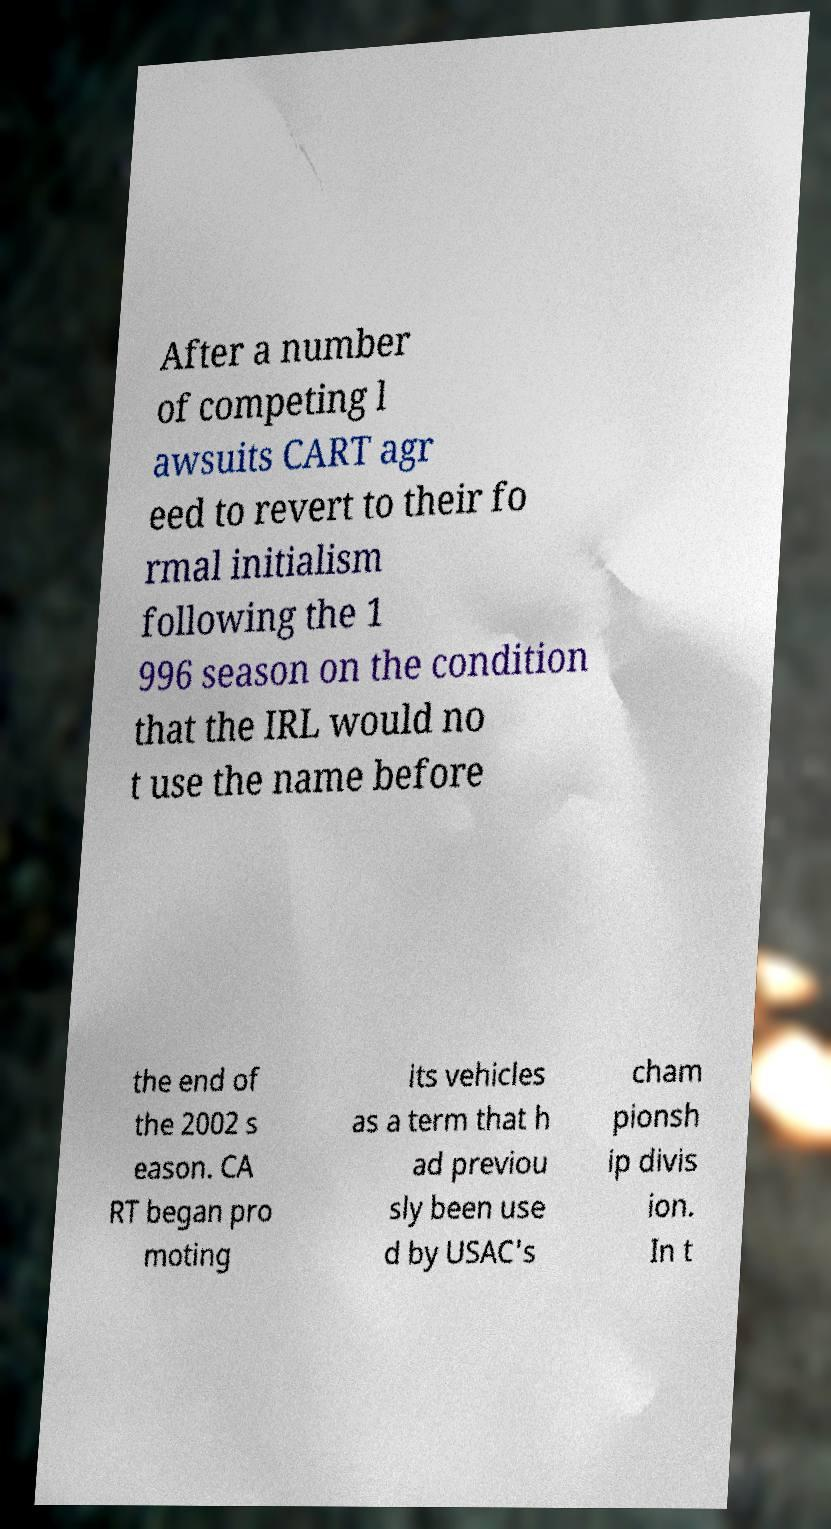Please read and relay the text visible in this image. What does it say? After a number of competing l awsuits CART agr eed to revert to their fo rmal initialism following the 1 996 season on the condition that the IRL would no t use the name before the end of the 2002 s eason. CA RT began pro moting its vehicles as a term that h ad previou sly been use d by USAC's cham pionsh ip divis ion. In t 